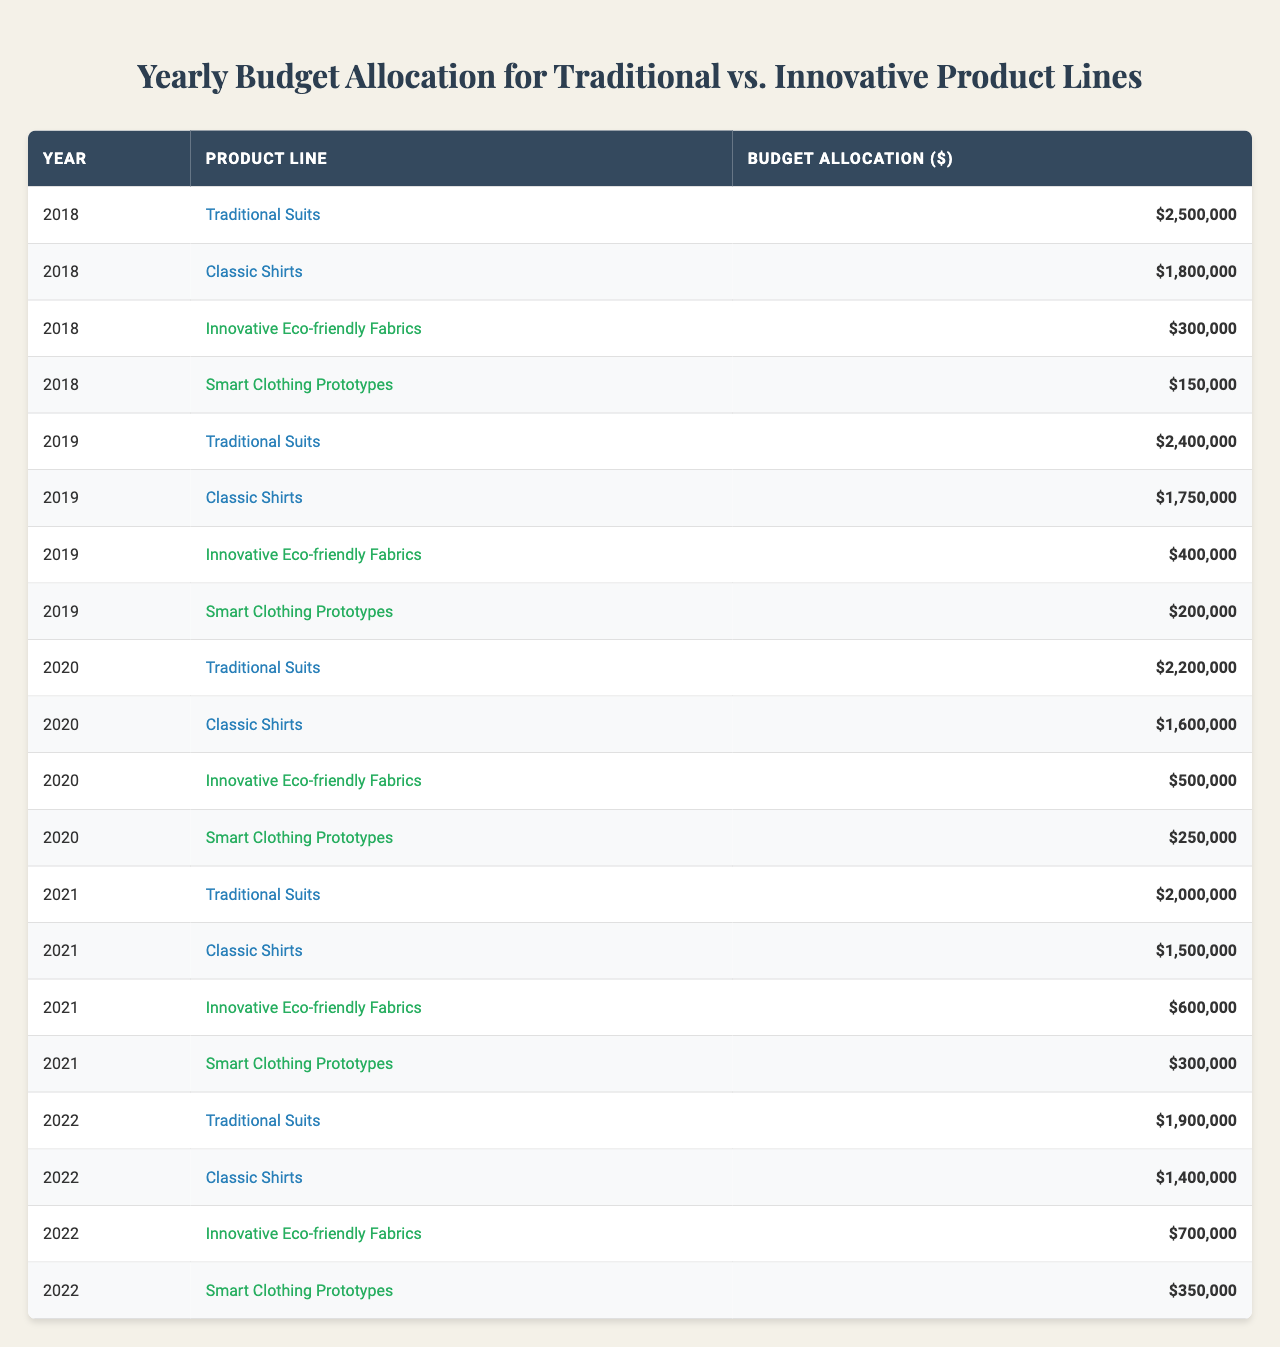What was the budget allocation for Innovative Eco-friendly Fabrics in 2020? In 2020, the budget allocation for Innovative Eco-friendly Fabrics is listed in the table as $500,000.
Answer: $500,000 How much did the budget for Smart Clothing Prototypes decrease from 2018 to 2022? The budget for Smart Clothing Prototypes in 2018 was $150,000, and in 2022 it was $350,000. The decrease from 2018 to 2022 is $150,000 - $350,000 = $-200,000 (an increase, not a decrease).
Answer: Increase of $200,000 What is the total budget allocation for Traditional Suits from 2018 to 2022? By summing up the allocations for Traditional Suits: 2018 ($2,500,000) + 2019 ($2,400,000) + 2020 ($2,200,000) + 2021 ($2,000,000) + 2022 ($1,900,000) gives a total of $2,500,000 + $2,400,000 + $2,200,000 + $2,000,000 + $1,900,000 = $11,000,000.
Answer: $11,000,000 Did the budget for Classic Shirts decline each year from 2018 to 2022? By looking at the allocations for Classic Shirts: 2018 ($1,800,000) to 2022 ($1,400,000), we can see it declines each year: 2018 to 2019, 2019 to 2020, 2020 to 2021, and 2021 to 2022. Therefore, it did decline each year.
Answer: Yes What was the total budget allocated to Innovative product lines across all years? The total allocation for Innovative product lines (Eco-friendly Fabrics and Smart Clothing Prototypes) is calculated: Eco-friendly Fabrics ($300,000 + $400,000 + $500,000 + $600,000 + $700,000) and Smart Clothing Prototypes ($150,000 + $200,000 + $250,000 + $300,000 + $350,000). The sums are $2,500,000 for Eco-friendly Fabrics and $1,250,000 for Smart Clothing Prototypes, yielding a total of $3,750,000.
Answer: $3,750,000 How much more was spent on Traditional Suits compared to Innovative Eco-friendly Fabrics in 2021? The budget for Traditional Suits in 2021 was $2,000,000, and for Innovative Eco-friendly Fabrics it was $600,000. The difference is $2,000,000 - $600,000 = $1,400,000.
Answer: $1,400,000 Which year had the least budget allocation for Smart Clothing Prototypes? By comparing all entries for Smart Clothing Prototypes, the allocations were: 2018 ($150,000), 2019 ($200,000), 2020 ($250,000), 2021 ($300,000), and 2022 ($350,000). The least was in 2018 at $150,000.
Answer: 2018 